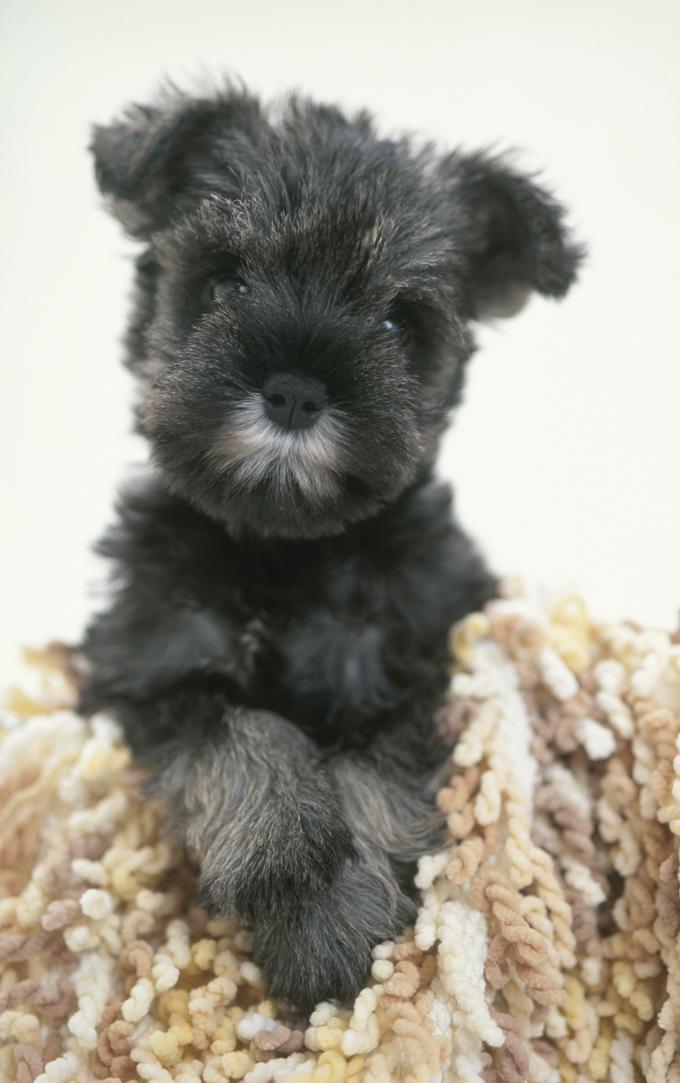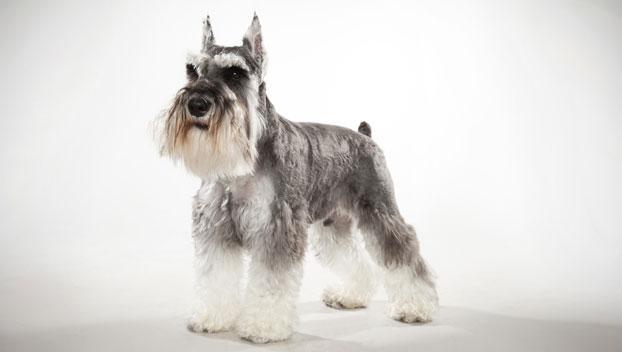The first image is the image on the left, the second image is the image on the right. Assess this claim about the two images: "An image contains a schnauzer standing and turned leftward.". Correct or not? Answer yes or no. Yes. 